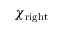<formula> <loc_0><loc_0><loc_500><loc_500>\chi _ { r i g h t }</formula> 